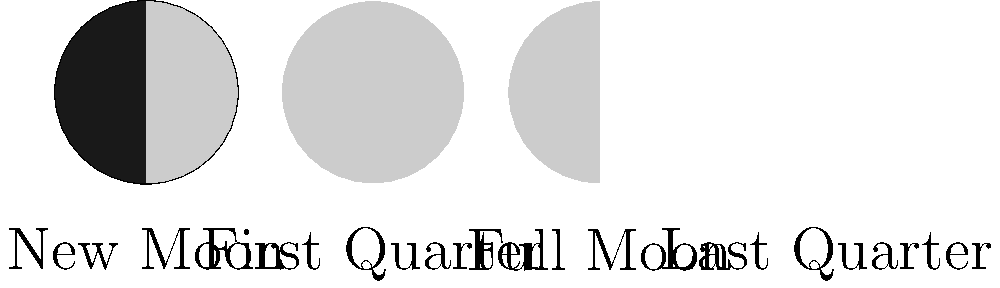In a television special about lunar phenomena, you're discussing the phases of the Moon. Using the circular diagrams above, which phase would occur approximately one week after the New Moon? To answer this question, we need to understand the lunar cycle and the sequence of Moon phases:

1. The lunar cycle, also known as the synodic month, lasts approximately 29.5 days.

2. The phases of the Moon progress in the following order:
   New Moon → Waxing Crescent → First Quarter → Waxing Gibbous → Full Moon → Waning Gibbous → Last Quarter → Waning Crescent → New Moon

3. Given that the entire cycle takes about 29.5 days, each major phase (New Moon, First Quarter, Full Moon, Last Quarter) occurs roughly every 7.4 days.

4. The question asks about the phase approximately one week after the New Moon.

5. Looking at the sequence, we can see that the First Quarter Moon occurs after the New Moon.

6. The circular diagrams in the image show the illuminated portion of the Moon as seen from Earth. The First Quarter Moon is represented by the second diagram from the left, where the right half of the circle is illuminated.

Therefore, approximately one week after the New Moon, we would observe the First Quarter Moon.
Answer: First Quarter Moon 